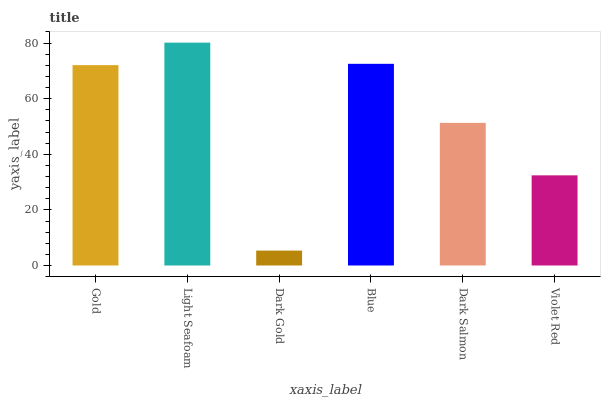Is Dark Gold the minimum?
Answer yes or no. Yes. Is Light Seafoam the maximum?
Answer yes or no. Yes. Is Light Seafoam the minimum?
Answer yes or no. No. Is Dark Gold the maximum?
Answer yes or no. No. Is Light Seafoam greater than Dark Gold?
Answer yes or no. Yes. Is Dark Gold less than Light Seafoam?
Answer yes or no. Yes. Is Dark Gold greater than Light Seafoam?
Answer yes or no. No. Is Light Seafoam less than Dark Gold?
Answer yes or no. No. Is Gold the high median?
Answer yes or no. Yes. Is Dark Salmon the low median?
Answer yes or no. Yes. Is Light Seafoam the high median?
Answer yes or no. No. Is Gold the low median?
Answer yes or no. No. 